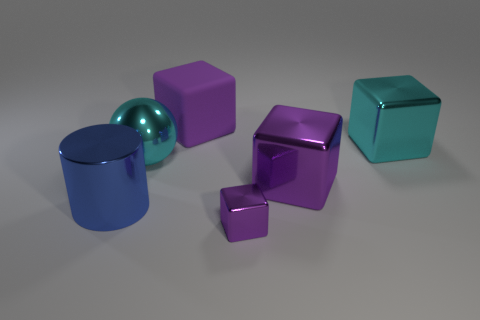Subtract all large cyan blocks. How many blocks are left? 3 Subtract all cubes. How many objects are left? 2 Subtract 1 cylinders. How many cylinders are left? 0 Subtract all large purple matte things. Subtract all spheres. How many objects are left? 4 Add 1 purple objects. How many purple objects are left? 4 Add 3 tiny purple blocks. How many tiny purple blocks exist? 4 Add 4 tiny cylinders. How many objects exist? 10 Subtract all purple cubes. How many cubes are left? 1 Subtract 2 purple cubes. How many objects are left? 4 Subtract all green spheres. Subtract all cyan cylinders. How many spheres are left? 1 